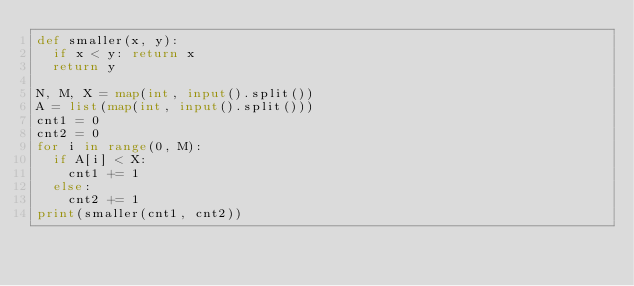<code> <loc_0><loc_0><loc_500><loc_500><_Python_>def smaller(x, y):
	if x < y: return x
	return y

N, M, X = map(int, input().split())
A = list(map(int, input().split()))
cnt1 = 0
cnt2 = 0
for i in range(0, M):
	if A[i] < X:
		cnt1 += 1
	else:
		cnt2 += 1
print(smaller(cnt1, cnt2))</code> 